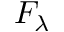<formula> <loc_0><loc_0><loc_500><loc_500>F _ { \lambda }</formula> 